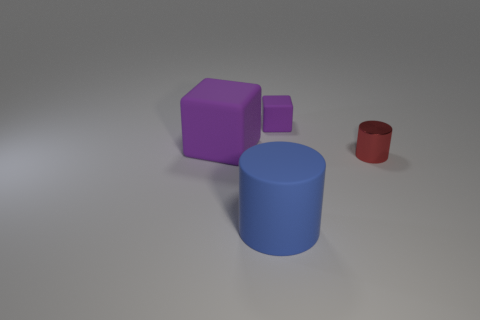What is the material of the small cylinder?
Your response must be concise. Metal. Do the metal object and the blue cylinder have the same size?
Offer a terse response. No. How many balls are tiny objects or tiny metallic objects?
Give a very brief answer. 0. The cylinder that is behind the thing that is in front of the small red metallic cylinder is what color?
Keep it short and to the point. Red. Are there fewer small rubber objects on the left side of the blue cylinder than tiny purple rubber blocks that are behind the small purple thing?
Your response must be concise. No. There is a shiny thing; does it have the same size as the purple rubber cube to the left of the big rubber cylinder?
Your answer should be compact. No. The object that is both on the left side of the small purple matte block and in front of the big rubber block has what shape?
Keep it short and to the point. Cylinder. What size is the purple block that is the same material as the small purple object?
Provide a short and direct response. Large. There is a purple thing that is in front of the small purple block; how many rubber blocks are to the right of it?
Give a very brief answer. 1. Is the cylinder left of the tiny purple block made of the same material as the tiny red object?
Provide a succinct answer. No. 